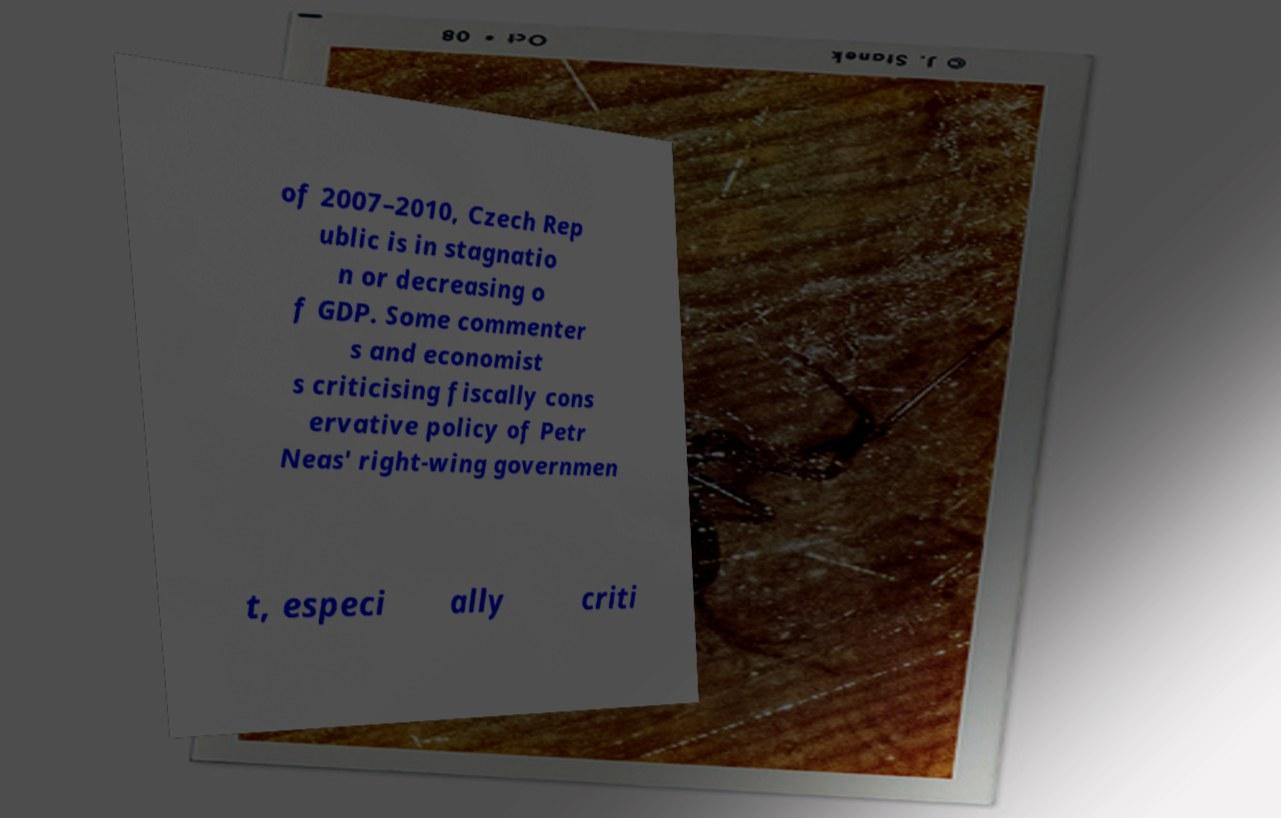Please identify and transcribe the text found in this image. of 2007–2010, Czech Rep ublic is in stagnatio n or decreasing o f GDP. Some commenter s and economist s criticising fiscally cons ervative policy of Petr Neas' right-wing governmen t, especi ally criti 